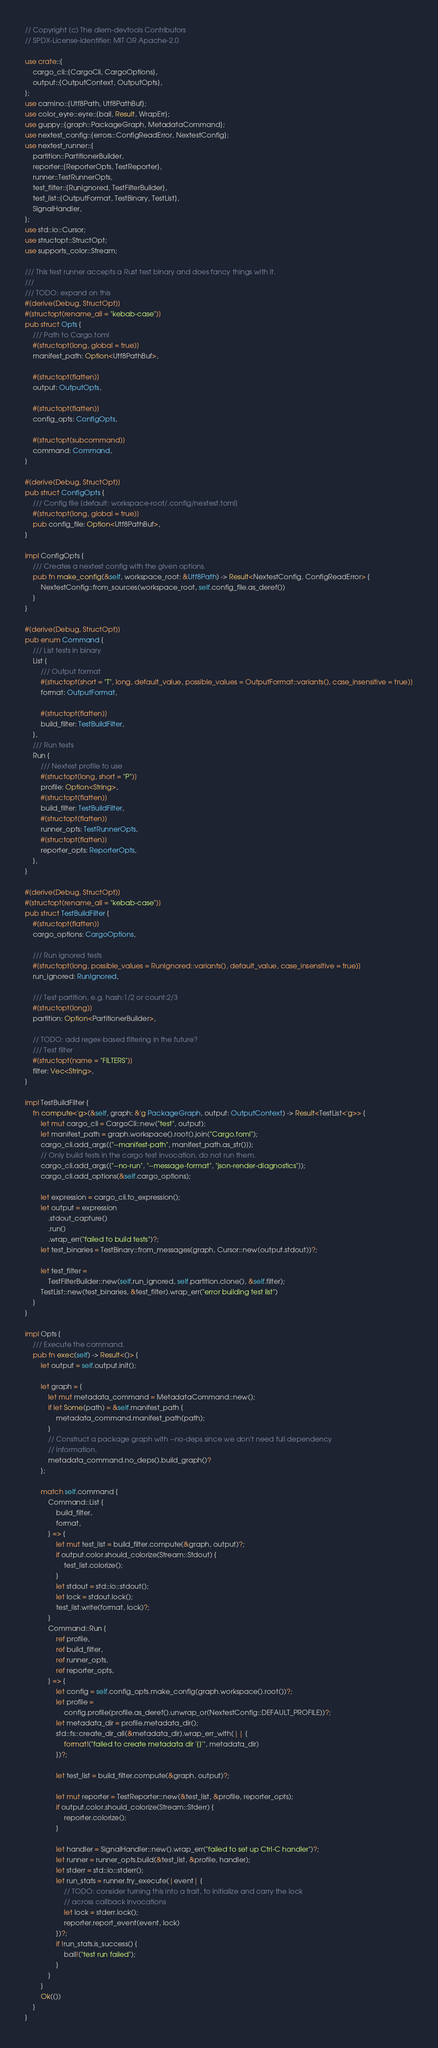Convert code to text. <code><loc_0><loc_0><loc_500><loc_500><_Rust_>// Copyright (c) The diem-devtools Contributors
// SPDX-License-Identifier: MIT OR Apache-2.0

use crate::{
    cargo_cli::{CargoCli, CargoOptions},
    output::{OutputContext, OutputOpts},
};
use camino::{Utf8Path, Utf8PathBuf};
use color_eyre::eyre::{bail, Result, WrapErr};
use guppy::{graph::PackageGraph, MetadataCommand};
use nextest_config::{errors::ConfigReadError, NextestConfig};
use nextest_runner::{
    partition::PartitionerBuilder,
    reporter::{ReporterOpts, TestReporter},
    runner::TestRunnerOpts,
    test_filter::{RunIgnored, TestFilterBuilder},
    test_list::{OutputFormat, TestBinary, TestList},
    SignalHandler,
};
use std::io::Cursor;
use structopt::StructOpt;
use supports_color::Stream;

/// This test runner accepts a Rust test binary and does fancy things with it.
///
/// TODO: expand on this
#[derive(Debug, StructOpt)]
#[structopt(rename_all = "kebab-case")]
pub struct Opts {
    /// Path to Cargo.toml
    #[structopt(long, global = true)]
    manifest_path: Option<Utf8PathBuf>,

    #[structopt(flatten)]
    output: OutputOpts,

    #[structopt(flatten)]
    config_opts: ConfigOpts,

    #[structopt(subcommand)]
    command: Command,
}

#[derive(Debug, StructOpt)]
pub struct ConfigOpts {
    /// Config file [default: workspace-root/.config/nextest.toml]
    #[structopt(long, global = true)]
    pub config_file: Option<Utf8PathBuf>,
}

impl ConfigOpts {
    /// Creates a nextest config with the given options.
    pub fn make_config(&self, workspace_root: &Utf8Path) -> Result<NextestConfig, ConfigReadError> {
        NextestConfig::from_sources(workspace_root, self.config_file.as_deref())
    }
}

#[derive(Debug, StructOpt)]
pub enum Command {
    /// List tests in binary
    List {
        /// Output format
        #[structopt(short = "T", long, default_value, possible_values = OutputFormat::variants(), case_insensitive = true)]
        format: OutputFormat,

        #[structopt(flatten)]
        build_filter: TestBuildFilter,
    },
    /// Run tests
    Run {
        /// Nextest profile to use
        #[structopt(long, short = "P")]
        profile: Option<String>,
        #[structopt(flatten)]
        build_filter: TestBuildFilter,
        #[structopt(flatten)]
        runner_opts: TestRunnerOpts,
        #[structopt(flatten)]
        reporter_opts: ReporterOpts,
    },
}

#[derive(Debug, StructOpt)]
#[structopt(rename_all = "kebab-case")]
pub struct TestBuildFilter {
    #[structopt(flatten)]
    cargo_options: CargoOptions,

    /// Run ignored tests
    #[structopt(long, possible_values = RunIgnored::variants(), default_value, case_insensitive = true)]
    run_ignored: RunIgnored,

    /// Test partition, e.g. hash:1/2 or count:2/3
    #[structopt(long)]
    partition: Option<PartitionerBuilder>,

    // TODO: add regex-based filtering in the future?
    /// Test filter
    #[structopt(name = "FILTERS")]
    filter: Vec<String>,
}

impl TestBuildFilter {
    fn compute<'g>(&self, graph: &'g PackageGraph, output: OutputContext) -> Result<TestList<'g>> {
        let mut cargo_cli = CargoCli::new("test", output);
        let manifest_path = graph.workspace().root().join("Cargo.toml");
        cargo_cli.add_args(["--manifest-path", manifest_path.as_str()]);
        // Only build tests in the cargo test invocation, do not run them.
        cargo_cli.add_args(["--no-run", "--message-format", "json-render-diagnostics"]);
        cargo_cli.add_options(&self.cargo_options);

        let expression = cargo_cli.to_expression();
        let output = expression
            .stdout_capture()
            .run()
            .wrap_err("failed to build tests")?;
        let test_binaries = TestBinary::from_messages(graph, Cursor::new(output.stdout))?;

        let test_filter =
            TestFilterBuilder::new(self.run_ignored, self.partition.clone(), &self.filter);
        TestList::new(test_binaries, &test_filter).wrap_err("error building test list")
    }
}

impl Opts {
    /// Execute the command.
    pub fn exec(self) -> Result<()> {
        let output = self.output.init();

        let graph = {
            let mut metadata_command = MetadataCommand::new();
            if let Some(path) = &self.manifest_path {
                metadata_command.manifest_path(path);
            }
            // Construct a package graph with --no-deps since we don't need full dependency
            // information.
            metadata_command.no_deps().build_graph()?
        };

        match self.command {
            Command::List {
                build_filter,
                format,
            } => {
                let mut test_list = build_filter.compute(&graph, output)?;
                if output.color.should_colorize(Stream::Stdout) {
                    test_list.colorize();
                }
                let stdout = std::io::stdout();
                let lock = stdout.lock();
                test_list.write(format, lock)?;
            }
            Command::Run {
                ref profile,
                ref build_filter,
                ref runner_opts,
                ref reporter_opts,
            } => {
                let config = self.config_opts.make_config(graph.workspace().root())?;
                let profile =
                    config.profile(profile.as_deref().unwrap_or(NextestConfig::DEFAULT_PROFILE))?;
                let metadata_dir = profile.metadata_dir();
                std::fs::create_dir_all(&metadata_dir).wrap_err_with(|| {
                    format!("failed to create metadata dir '{}'", metadata_dir)
                })?;

                let test_list = build_filter.compute(&graph, output)?;

                let mut reporter = TestReporter::new(&test_list, &profile, reporter_opts);
                if output.color.should_colorize(Stream::Stderr) {
                    reporter.colorize();
                }

                let handler = SignalHandler::new().wrap_err("failed to set up Ctrl-C handler")?;
                let runner = runner_opts.build(&test_list, &profile, handler);
                let stderr = std::io::stderr();
                let run_stats = runner.try_execute(|event| {
                    // TODO: consider turning this into a trait, to initialize and carry the lock
                    // across callback invocations
                    let lock = stderr.lock();
                    reporter.report_event(event, lock)
                })?;
                if !run_stats.is_success() {
                    bail!("test run failed");
                }
            }
        }
        Ok(())
    }
}
</code> 